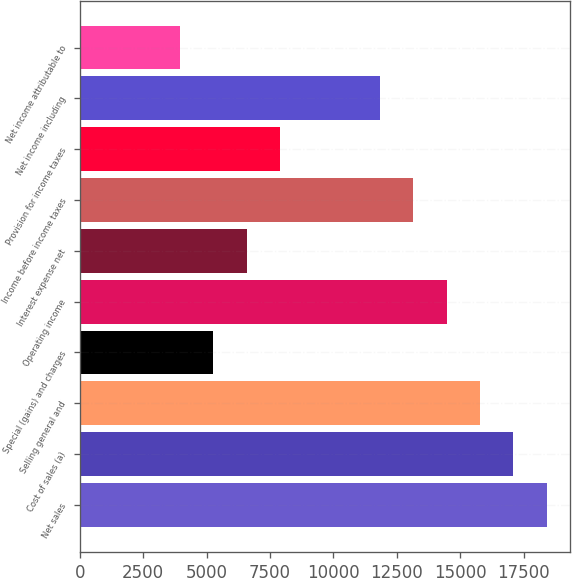Convert chart to OTSL. <chart><loc_0><loc_0><loc_500><loc_500><bar_chart><fcel>Net sales<fcel>Cost of sales (a)<fcel>Selling general and<fcel>Special (gains) and charges<fcel>Operating income<fcel>Interest expense net<fcel>Income before income taxes<fcel>Provision for income taxes<fcel>Net income including<fcel>Net income attributable to<nl><fcel>18412.3<fcel>17097.5<fcel>15782.6<fcel>5263.62<fcel>14467.7<fcel>6578.49<fcel>13152.8<fcel>7893.36<fcel>11838<fcel>3948.75<nl></chart> 